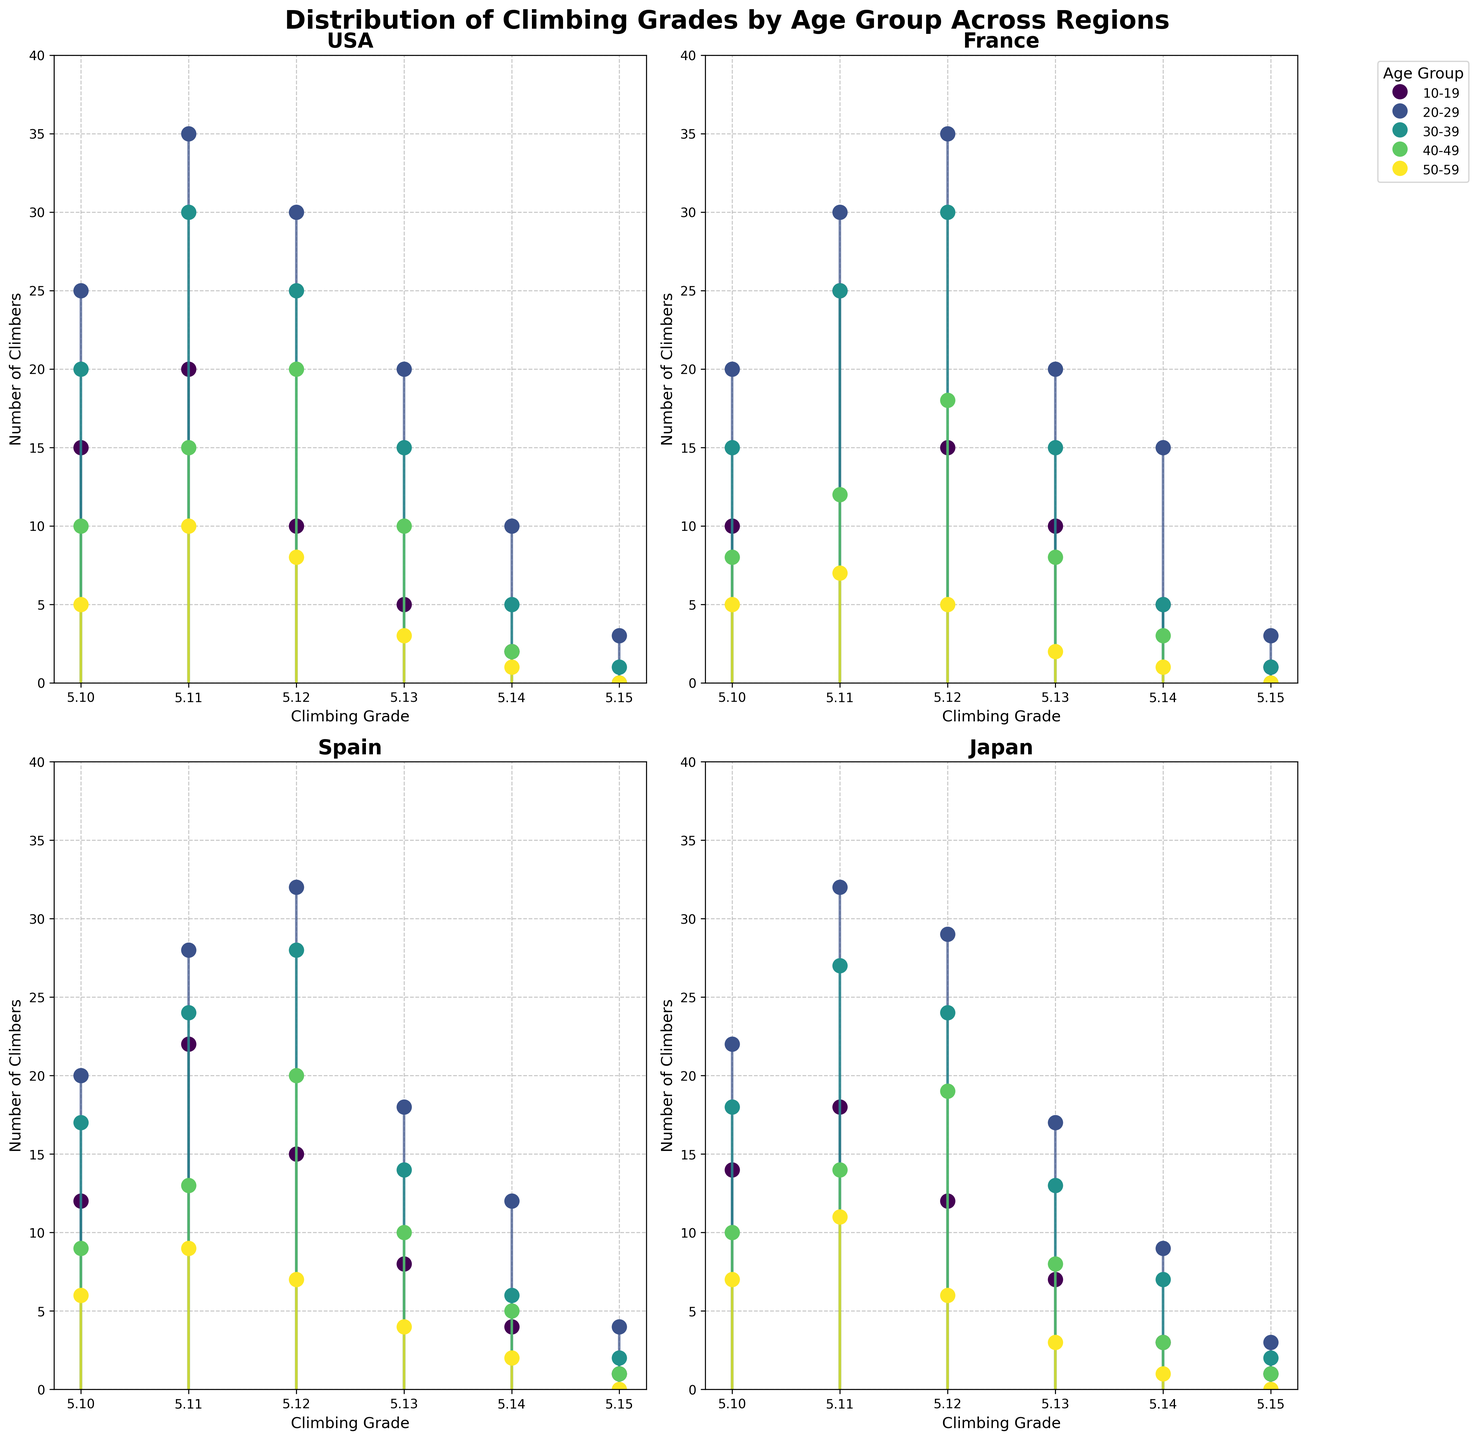What are the age groups shown in the plots? The age groups are indicated in the legend and apply across all subplots. They are "10-19", "20-29", "30-39", "40-49", and "50-59".
Answer: 10-19, 20-29, 30-39, 40-49, 50-59 Which region shows the highest single count for the 5.14 grade? By looking at the counts for the 5.14 grade in each subplot, the highest count is in the France region, showing the highest value for the 20-29 age group, with 15 climbers.
Answer: France In the Japan subplot, how many total climbers achieve grades 5.12 or higher in the 30-39 age group? For the Japan region and 30-39 age group, add the counts for grades 5.12, 5.13, 5.14, and 5.15: 24 (5.12) + 13 (5.13) + 7 (5.14) + 2 (5.15) = 46 climbers.
Answer: 46 Which age group in the USA has the most climbers achieving the 5.11 grade? In the USA subplot, the 20-29 age group shows the highest count of 35 climbers for the 5.11 grade.
Answer: 20-29 Compare the total number of climbers achieving the 5.15 grade in Spain and Japan. Which region has more? In the Spain subplot, there are 1 (10-19) + 4 (20-29) + 2 (30-39) + 1 (40-49) + 0 (50-59) = 8 climbers. In Japan, there are 1 (10-19) + 3 (20-29) + 2 (30-39) + 1 (40-49) + 0 (50-59) = 7 climbers. Spain has more.
Answer: Spain What is the average number of climbers achieving the 5.12 grade across all age groups in France? In the France subplot, sum the 5.12 grade counts for all age groups and divide by the number of age groups: (15 + 35 + 30 + 18 + 5) / 5 = 20.6 climbers on average.
Answer: 20.6 In which region and age group do climbers achieve the highest count in the 5.13 grade? By comparing all subplots, the highest count for the 5.13 grade is in the France region for the 20-29 age group, with 20 climbers.
Answer: France, 20-29 For the USA region, what is the total number of climbers across all age groups achieving the 5.15 grade? In the USA subplot, sum the 5.15 grade counts across all age groups: 0 (10-19) + 3 (20-29) + 1 (30-39) + 0 (40-49) + 0 (50-59) = 4 climbers.
Answer: 4 In Spain, which age group has the highest total count for grades 5.10 and 5.11 combined? In the Spain subplot, add the counts for grades 5.10 and 5.11 for each age group. The highest combined count is for the 20-29 age group: 20 (5.10) + 28 (5.11) = 48 climbers.
Answer: 20-29 